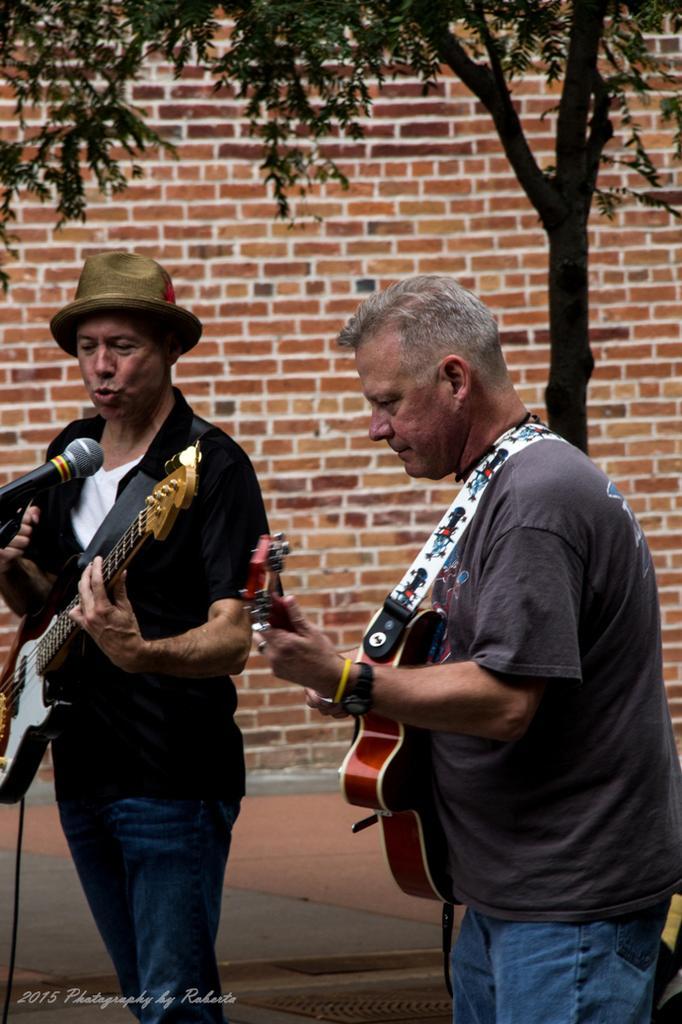Describe this image in one or two sentences. In this picture we can see two persons standing and playing guitar. He wear a cap and he is singing on the mike. And on the background there is a brick wall. And this is the tree. 